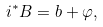<formula> <loc_0><loc_0><loc_500><loc_500>i ^ { * } B = b + \varphi ,</formula> 